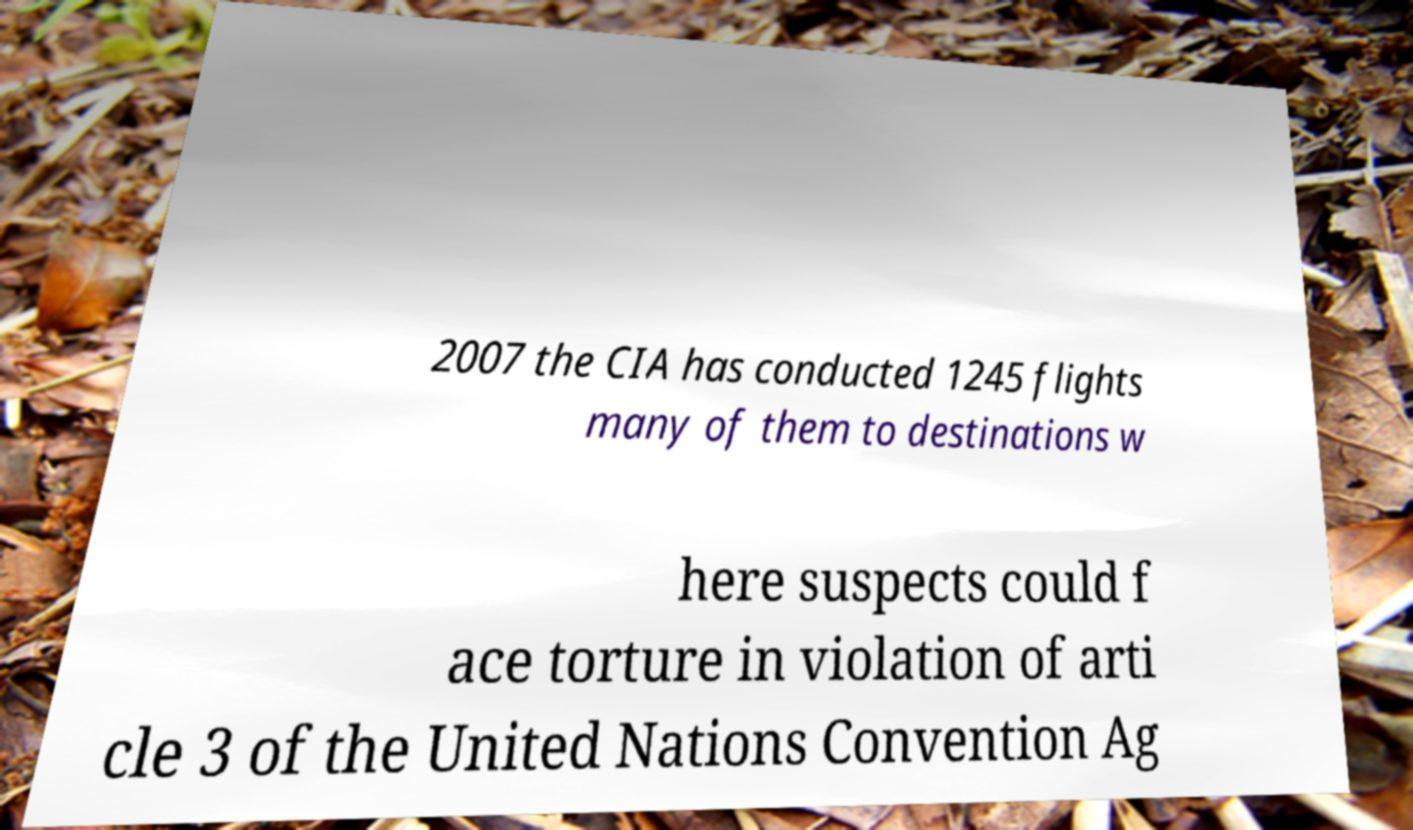Can you accurately transcribe the text from the provided image for me? 2007 the CIA has conducted 1245 flights many of them to destinations w here suspects could f ace torture in violation of arti cle 3 of the United Nations Convention Ag 